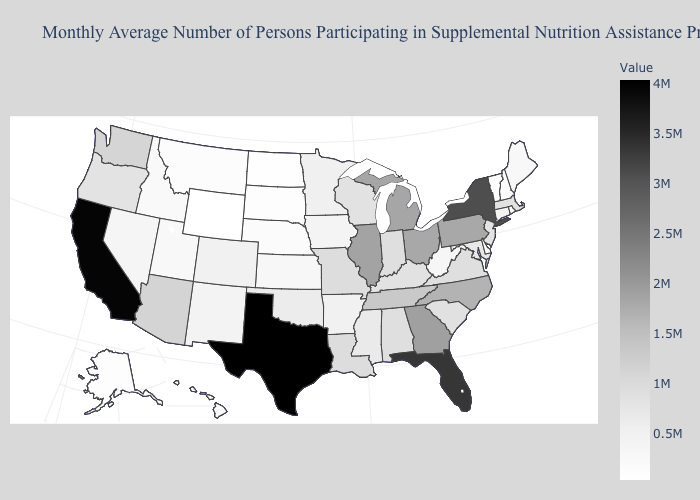Among the states that border Vermont , which have the lowest value?
Quick response, please. New Hampshire. Among the states that border Georgia , does South Carolina have the lowest value?
Quick response, please. Yes. Does the map have missing data?
Concise answer only. No. Among the states that border Kansas , which have the lowest value?
Write a very short answer. Nebraska. Among the states that border Ohio , which have the lowest value?
Give a very brief answer. West Virginia. 